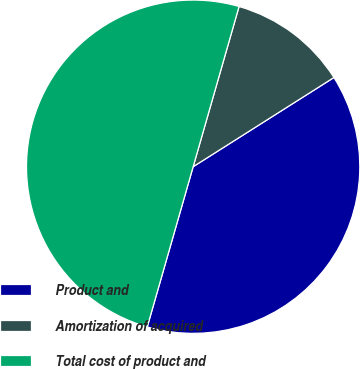Convert chart. <chart><loc_0><loc_0><loc_500><loc_500><pie_chart><fcel>Product and<fcel>Amortization of acquired<fcel>Total cost of product and<nl><fcel>38.43%<fcel>11.57%<fcel>50.0%<nl></chart> 